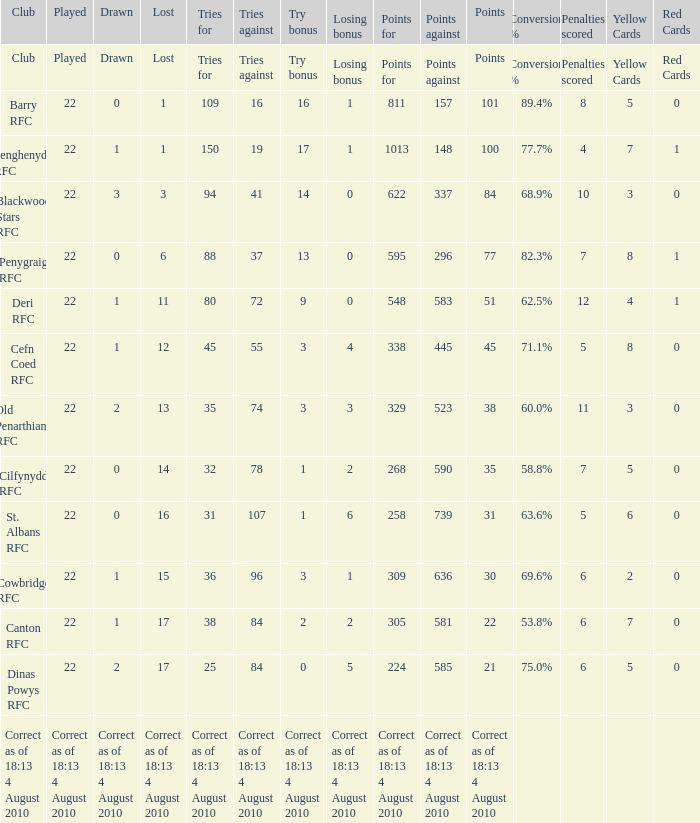What is the points when the lost was 11? 548.0. 